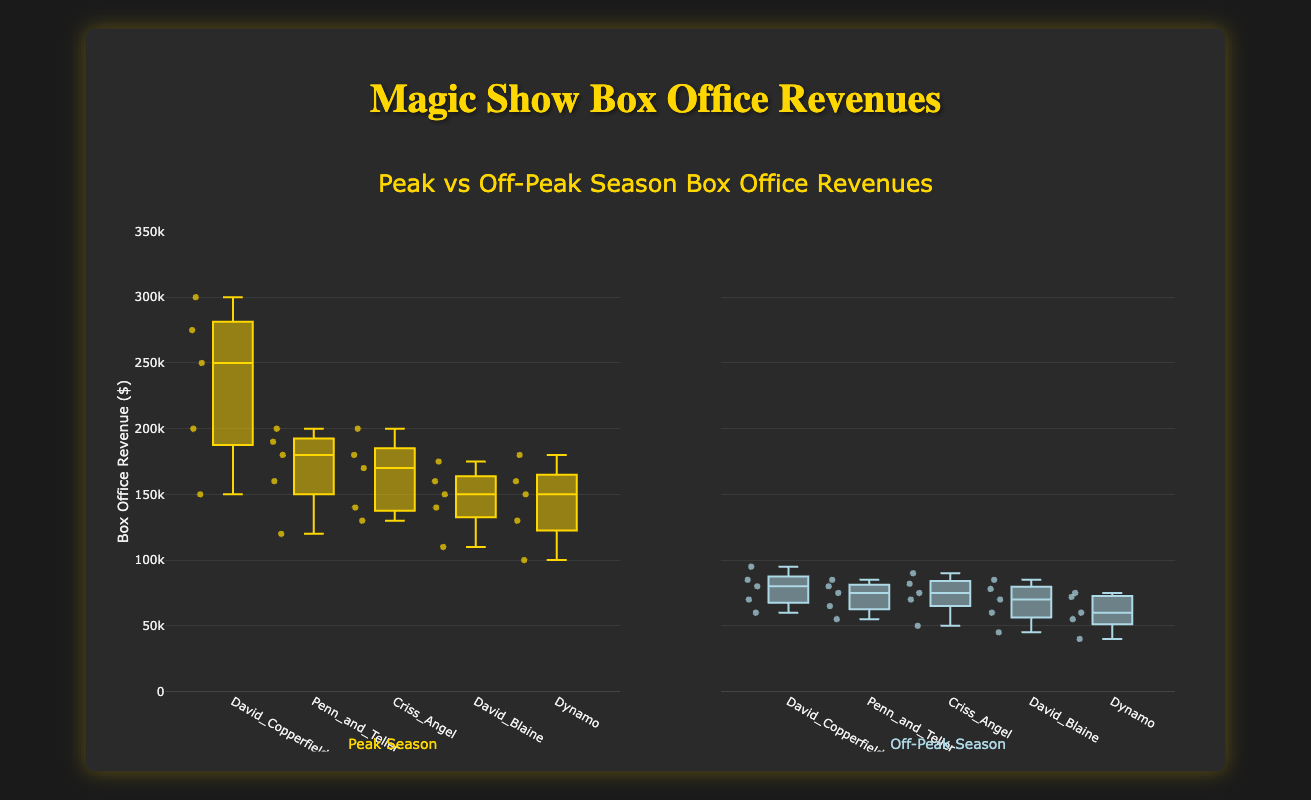What is the title of the figure? The title of the figure is positioned at the top and displayed in a larger, bold font. It indicates the subject of the data being visualized.
Answer: Peak vs Off-Peak Season Box Office Revenues What does the y-axis represent? The y-axis is labeled with the title "Box Office Revenue ($)" and represents the box office revenues from magic shows in dollars.
Answer: Box Office Revenue ($) Which season generally shows higher revenues for David Copperfield? Compare the positions of the boxes for David Copperfield in both Peak and Off-Peak seasons. The peak season boxes are significantly higher in value.
Answer: Peak Season What color represents Peak Season on the plot? The plot uses color differentiation for the two seasons. Peak Season data is represented by a yellowish color as seen in the boxes associated with the data points for Peak Season.
Answer: Yellow Which magician has the highest median revenue during Peak Season? Look at the center line of the boxes (median line) in the Peak Season section. David Copperfield's box has the highest median line near the top.
Answer: David Copperfield Which season shows more variability in revenues for Dynamo? Compare the interquartile range (distance between the top and bottom of the box) for Dynamo in both seasons. The Peak Season box is more spread out, indicating higher variability.
Answer: Peak Season What is the range of box office revenues for Penn and Teller during Off-Peak Season? Identify the bottom and top whiskers of the Penn and Teller's box during the Off-Peak season. The lowest value is 55,000 and the highest is 85,000.
Answer: 30,000 (55,000 to 85,000) Who had a lower minimum revenue during Peak Season, David Blaine or Dynamo? Look at the bottom whisker of the boxes for David Blaine and Dynamo during Peak Season. David Blaine has a lower minimum value at 110,000.
Answer: David Blaine Compare the revenue medians of Criss Angel in both Peak and Off-Peak Seasons. Look at the center lines in the Criss Angel's boxes for both seasons. The median during Peak Season is higher than during Off-Peak Season.
Answer: Higher in Peak Season Which magician has a smaller interquartile range during Off-Peak Season, Criss Angel or Dynamo? The interquartile range is the distance between the top and bottom of the box. Criss Angel's box during Off-Peak Season is more compact compared to Dynamo's.
Answer: Criss Angel 